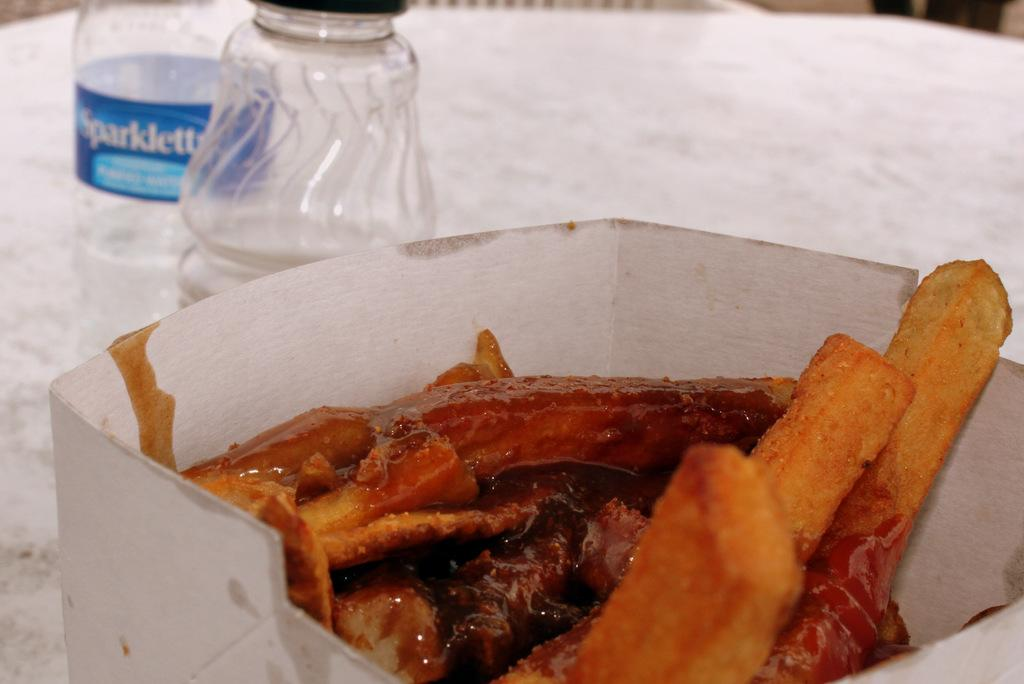<image>
Describe the image concisely. Empty bottle of Sparklett sits behind a bowl of french fries. 